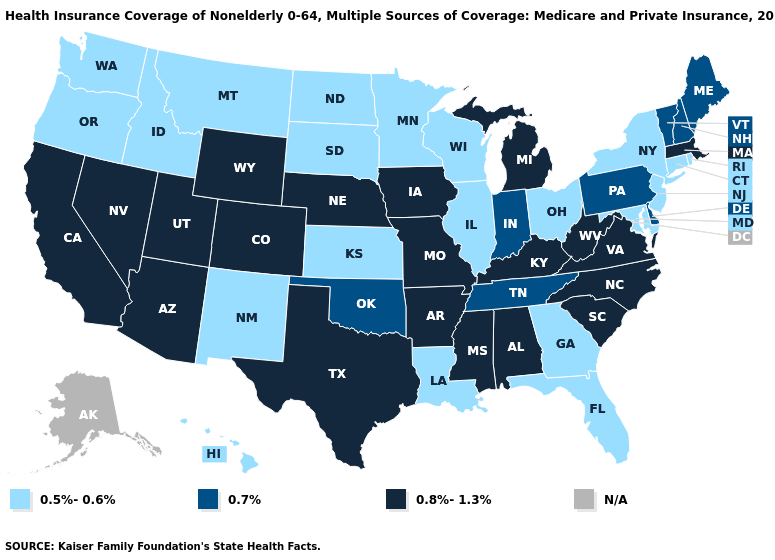Among the states that border Wisconsin , which have the highest value?
Write a very short answer. Iowa, Michigan. What is the value of Pennsylvania?
Concise answer only. 0.7%. What is the highest value in the USA?
Short answer required. 0.8%-1.3%. What is the lowest value in the Northeast?
Keep it brief. 0.5%-0.6%. What is the highest value in the Northeast ?
Give a very brief answer. 0.8%-1.3%. What is the highest value in states that border South Carolina?
Concise answer only. 0.8%-1.3%. Does Maine have the highest value in the USA?
Quick response, please. No. Name the states that have a value in the range 0.5%-0.6%?
Quick response, please. Connecticut, Florida, Georgia, Hawaii, Idaho, Illinois, Kansas, Louisiana, Maryland, Minnesota, Montana, New Jersey, New Mexico, New York, North Dakota, Ohio, Oregon, Rhode Island, South Dakota, Washington, Wisconsin. Is the legend a continuous bar?
Keep it brief. No. Is the legend a continuous bar?
Answer briefly. No. What is the lowest value in states that border South Carolina?
Answer briefly. 0.5%-0.6%. Does California have the lowest value in the USA?
Answer briefly. No. Name the states that have a value in the range 0.5%-0.6%?
Quick response, please. Connecticut, Florida, Georgia, Hawaii, Idaho, Illinois, Kansas, Louisiana, Maryland, Minnesota, Montana, New Jersey, New Mexico, New York, North Dakota, Ohio, Oregon, Rhode Island, South Dakota, Washington, Wisconsin. What is the value of Delaware?
Write a very short answer. 0.7%. 